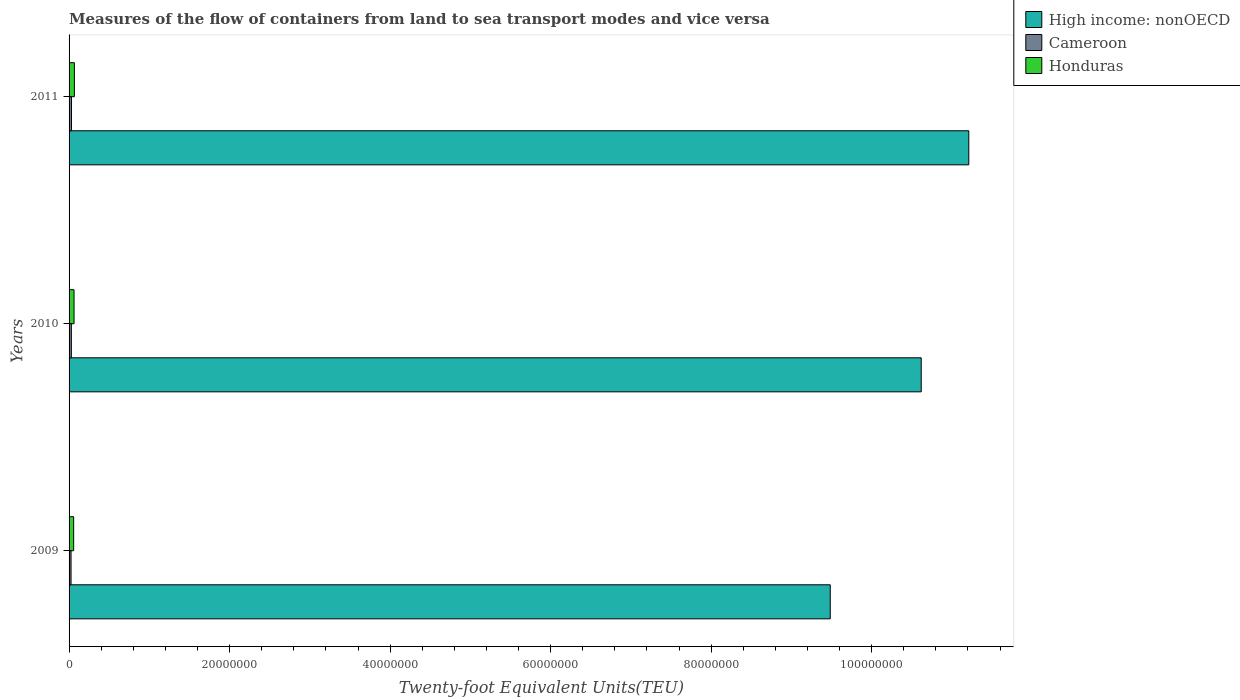Are the number of bars on each tick of the Y-axis equal?
Ensure brevity in your answer.  Yes. How many bars are there on the 1st tick from the top?
Your response must be concise. 3. How many bars are there on the 2nd tick from the bottom?
Your answer should be compact. 3. What is the label of the 3rd group of bars from the top?
Make the answer very short. 2009. In how many cases, is the number of bars for a given year not equal to the number of legend labels?
Offer a terse response. 0. What is the container port traffic in High income: nonOECD in 2011?
Offer a very short reply. 1.12e+08. Across all years, what is the maximum container port traffic in High income: nonOECD?
Make the answer very short. 1.12e+08. Across all years, what is the minimum container port traffic in Honduras?
Keep it short and to the point. 5.72e+05. What is the total container port traffic in Cameroon in the graph?
Offer a very short reply. 8.32e+05. What is the difference between the container port traffic in Honduras in 2010 and that in 2011?
Your response must be concise. -4.26e+04. What is the difference between the container port traffic in High income: nonOECD in 2010 and the container port traffic in Honduras in 2011?
Give a very brief answer. 1.06e+08. What is the average container port traffic in Honduras per year?
Offer a very short reply. 6.18e+05. In the year 2011, what is the difference between the container port traffic in Honduras and container port traffic in Cameroon?
Offer a very short reply. 3.61e+05. In how many years, is the container port traffic in Honduras greater than 12000000 TEU?
Offer a terse response. 0. What is the ratio of the container port traffic in Cameroon in 2009 to that in 2010?
Make the answer very short. 0.86. Is the container port traffic in Honduras in 2009 less than that in 2010?
Offer a terse response. Yes. What is the difference between the highest and the second highest container port traffic in Honduras?
Your answer should be compact. 4.26e+04. What is the difference between the highest and the lowest container port traffic in High income: nonOECD?
Provide a short and direct response. 1.73e+07. In how many years, is the container port traffic in Cameroon greater than the average container port traffic in Cameroon taken over all years?
Give a very brief answer. 2. What does the 3rd bar from the top in 2011 represents?
Give a very brief answer. High income: nonOECD. What does the 2nd bar from the bottom in 2010 represents?
Give a very brief answer. Cameroon. Is it the case that in every year, the sum of the container port traffic in High income: nonOECD and container port traffic in Honduras is greater than the container port traffic in Cameroon?
Your answer should be compact. Yes. How many years are there in the graph?
Your answer should be compact. 3. What is the difference between two consecutive major ticks on the X-axis?
Provide a short and direct response. 2.00e+07. Are the values on the major ticks of X-axis written in scientific E-notation?
Your answer should be very brief. No. Does the graph contain any zero values?
Ensure brevity in your answer.  No. How many legend labels are there?
Make the answer very short. 3. How are the legend labels stacked?
Your response must be concise. Vertical. What is the title of the graph?
Provide a succinct answer. Measures of the flow of containers from land to sea transport modes and vice versa. What is the label or title of the X-axis?
Your response must be concise. Twenty-foot Equivalent Units(TEU). What is the label or title of the Y-axis?
Your answer should be compact. Years. What is the Twenty-foot Equivalent Units(TEU) of High income: nonOECD in 2009?
Give a very brief answer. 9.48e+07. What is the Twenty-foot Equivalent Units(TEU) in Cameroon in 2009?
Your answer should be compact. 2.46e+05. What is the Twenty-foot Equivalent Units(TEU) in Honduras in 2009?
Your response must be concise. 5.72e+05. What is the Twenty-foot Equivalent Units(TEU) in High income: nonOECD in 2010?
Ensure brevity in your answer.  1.06e+08. What is the Twenty-foot Equivalent Units(TEU) of Cameroon in 2010?
Give a very brief answer. 2.85e+05. What is the Twenty-foot Equivalent Units(TEU) in Honduras in 2010?
Offer a terse response. 6.20e+05. What is the Twenty-foot Equivalent Units(TEU) in High income: nonOECD in 2011?
Your answer should be compact. 1.12e+08. What is the Twenty-foot Equivalent Units(TEU) in Cameroon in 2011?
Your response must be concise. 3.01e+05. What is the Twenty-foot Equivalent Units(TEU) in Honduras in 2011?
Your answer should be very brief. 6.62e+05. Across all years, what is the maximum Twenty-foot Equivalent Units(TEU) of High income: nonOECD?
Keep it short and to the point. 1.12e+08. Across all years, what is the maximum Twenty-foot Equivalent Units(TEU) of Cameroon?
Make the answer very short. 3.01e+05. Across all years, what is the maximum Twenty-foot Equivalent Units(TEU) of Honduras?
Provide a short and direct response. 6.62e+05. Across all years, what is the minimum Twenty-foot Equivalent Units(TEU) of High income: nonOECD?
Ensure brevity in your answer.  9.48e+07. Across all years, what is the minimum Twenty-foot Equivalent Units(TEU) of Cameroon?
Your answer should be very brief. 2.46e+05. Across all years, what is the minimum Twenty-foot Equivalent Units(TEU) of Honduras?
Provide a short and direct response. 5.72e+05. What is the total Twenty-foot Equivalent Units(TEU) of High income: nonOECD in the graph?
Provide a succinct answer. 3.13e+08. What is the total Twenty-foot Equivalent Units(TEU) of Cameroon in the graph?
Your answer should be very brief. 8.32e+05. What is the total Twenty-foot Equivalent Units(TEU) of Honduras in the graph?
Provide a succinct answer. 1.85e+06. What is the difference between the Twenty-foot Equivalent Units(TEU) of High income: nonOECD in 2009 and that in 2010?
Keep it short and to the point. -1.13e+07. What is the difference between the Twenty-foot Equivalent Units(TEU) of Cameroon in 2009 and that in 2010?
Provide a short and direct response. -3.95e+04. What is the difference between the Twenty-foot Equivalent Units(TEU) of Honduras in 2009 and that in 2010?
Your response must be concise. -4.81e+04. What is the difference between the Twenty-foot Equivalent Units(TEU) of High income: nonOECD in 2009 and that in 2011?
Offer a very short reply. -1.73e+07. What is the difference between the Twenty-foot Equivalent Units(TEU) in Cameroon in 2009 and that in 2011?
Provide a short and direct response. -5.58e+04. What is the difference between the Twenty-foot Equivalent Units(TEU) of Honduras in 2009 and that in 2011?
Offer a terse response. -9.07e+04. What is the difference between the Twenty-foot Equivalent Units(TEU) in High income: nonOECD in 2010 and that in 2011?
Your response must be concise. -5.93e+06. What is the difference between the Twenty-foot Equivalent Units(TEU) of Cameroon in 2010 and that in 2011?
Provide a short and direct response. -1.62e+04. What is the difference between the Twenty-foot Equivalent Units(TEU) in Honduras in 2010 and that in 2011?
Your response must be concise. -4.26e+04. What is the difference between the Twenty-foot Equivalent Units(TEU) of High income: nonOECD in 2009 and the Twenty-foot Equivalent Units(TEU) of Cameroon in 2010?
Keep it short and to the point. 9.46e+07. What is the difference between the Twenty-foot Equivalent Units(TEU) in High income: nonOECD in 2009 and the Twenty-foot Equivalent Units(TEU) in Honduras in 2010?
Your answer should be very brief. 9.42e+07. What is the difference between the Twenty-foot Equivalent Units(TEU) of Cameroon in 2009 and the Twenty-foot Equivalent Units(TEU) of Honduras in 2010?
Your answer should be very brief. -3.74e+05. What is the difference between the Twenty-foot Equivalent Units(TEU) of High income: nonOECD in 2009 and the Twenty-foot Equivalent Units(TEU) of Cameroon in 2011?
Provide a short and direct response. 9.45e+07. What is the difference between the Twenty-foot Equivalent Units(TEU) in High income: nonOECD in 2009 and the Twenty-foot Equivalent Units(TEU) in Honduras in 2011?
Offer a very short reply. 9.42e+07. What is the difference between the Twenty-foot Equivalent Units(TEU) in Cameroon in 2009 and the Twenty-foot Equivalent Units(TEU) in Honduras in 2011?
Your answer should be very brief. -4.17e+05. What is the difference between the Twenty-foot Equivalent Units(TEU) of High income: nonOECD in 2010 and the Twenty-foot Equivalent Units(TEU) of Cameroon in 2011?
Make the answer very short. 1.06e+08. What is the difference between the Twenty-foot Equivalent Units(TEU) of High income: nonOECD in 2010 and the Twenty-foot Equivalent Units(TEU) of Honduras in 2011?
Your answer should be compact. 1.06e+08. What is the difference between the Twenty-foot Equivalent Units(TEU) in Cameroon in 2010 and the Twenty-foot Equivalent Units(TEU) in Honduras in 2011?
Offer a very short reply. -3.77e+05. What is the average Twenty-foot Equivalent Units(TEU) of High income: nonOECD per year?
Ensure brevity in your answer.  1.04e+08. What is the average Twenty-foot Equivalent Units(TEU) in Cameroon per year?
Offer a terse response. 2.77e+05. What is the average Twenty-foot Equivalent Units(TEU) in Honduras per year?
Offer a terse response. 6.18e+05. In the year 2009, what is the difference between the Twenty-foot Equivalent Units(TEU) in High income: nonOECD and Twenty-foot Equivalent Units(TEU) in Cameroon?
Provide a succinct answer. 9.46e+07. In the year 2009, what is the difference between the Twenty-foot Equivalent Units(TEU) of High income: nonOECD and Twenty-foot Equivalent Units(TEU) of Honduras?
Keep it short and to the point. 9.43e+07. In the year 2009, what is the difference between the Twenty-foot Equivalent Units(TEU) in Cameroon and Twenty-foot Equivalent Units(TEU) in Honduras?
Your response must be concise. -3.26e+05. In the year 2010, what is the difference between the Twenty-foot Equivalent Units(TEU) of High income: nonOECD and Twenty-foot Equivalent Units(TEU) of Cameroon?
Make the answer very short. 1.06e+08. In the year 2010, what is the difference between the Twenty-foot Equivalent Units(TEU) in High income: nonOECD and Twenty-foot Equivalent Units(TEU) in Honduras?
Offer a very short reply. 1.06e+08. In the year 2010, what is the difference between the Twenty-foot Equivalent Units(TEU) of Cameroon and Twenty-foot Equivalent Units(TEU) of Honduras?
Offer a very short reply. -3.35e+05. In the year 2011, what is the difference between the Twenty-foot Equivalent Units(TEU) of High income: nonOECD and Twenty-foot Equivalent Units(TEU) of Cameroon?
Your answer should be compact. 1.12e+08. In the year 2011, what is the difference between the Twenty-foot Equivalent Units(TEU) in High income: nonOECD and Twenty-foot Equivalent Units(TEU) in Honduras?
Make the answer very short. 1.11e+08. In the year 2011, what is the difference between the Twenty-foot Equivalent Units(TEU) of Cameroon and Twenty-foot Equivalent Units(TEU) of Honduras?
Ensure brevity in your answer.  -3.61e+05. What is the ratio of the Twenty-foot Equivalent Units(TEU) in High income: nonOECD in 2009 to that in 2010?
Provide a short and direct response. 0.89. What is the ratio of the Twenty-foot Equivalent Units(TEU) of Cameroon in 2009 to that in 2010?
Provide a short and direct response. 0.86. What is the ratio of the Twenty-foot Equivalent Units(TEU) in Honduras in 2009 to that in 2010?
Provide a short and direct response. 0.92. What is the ratio of the Twenty-foot Equivalent Units(TEU) in High income: nonOECD in 2009 to that in 2011?
Make the answer very short. 0.85. What is the ratio of the Twenty-foot Equivalent Units(TEU) of Cameroon in 2009 to that in 2011?
Your response must be concise. 0.81. What is the ratio of the Twenty-foot Equivalent Units(TEU) in Honduras in 2009 to that in 2011?
Your answer should be compact. 0.86. What is the ratio of the Twenty-foot Equivalent Units(TEU) of High income: nonOECD in 2010 to that in 2011?
Give a very brief answer. 0.95. What is the ratio of the Twenty-foot Equivalent Units(TEU) of Cameroon in 2010 to that in 2011?
Provide a succinct answer. 0.95. What is the ratio of the Twenty-foot Equivalent Units(TEU) in Honduras in 2010 to that in 2011?
Your answer should be very brief. 0.94. What is the difference between the highest and the second highest Twenty-foot Equivalent Units(TEU) in High income: nonOECD?
Keep it short and to the point. 5.93e+06. What is the difference between the highest and the second highest Twenty-foot Equivalent Units(TEU) of Cameroon?
Your answer should be very brief. 1.62e+04. What is the difference between the highest and the second highest Twenty-foot Equivalent Units(TEU) in Honduras?
Your answer should be very brief. 4.26e+04. What is the difference between the highest and the lowest Twenty-foot Equivalent Units(TEU) in High income: nonOECD?
Keep it short and to the point. 1.73e+07. What is the difference between the highest and the lowest Twenty-foot Equivalent Units(TEU) of Cameroon?
Give a very brief answer. 5.58e+04. What is the difference between the highest and the lowest Twenty-foot Equivalent Units(TEU) of Honduras?
Your answer should be very brief. 9.07e+04. 